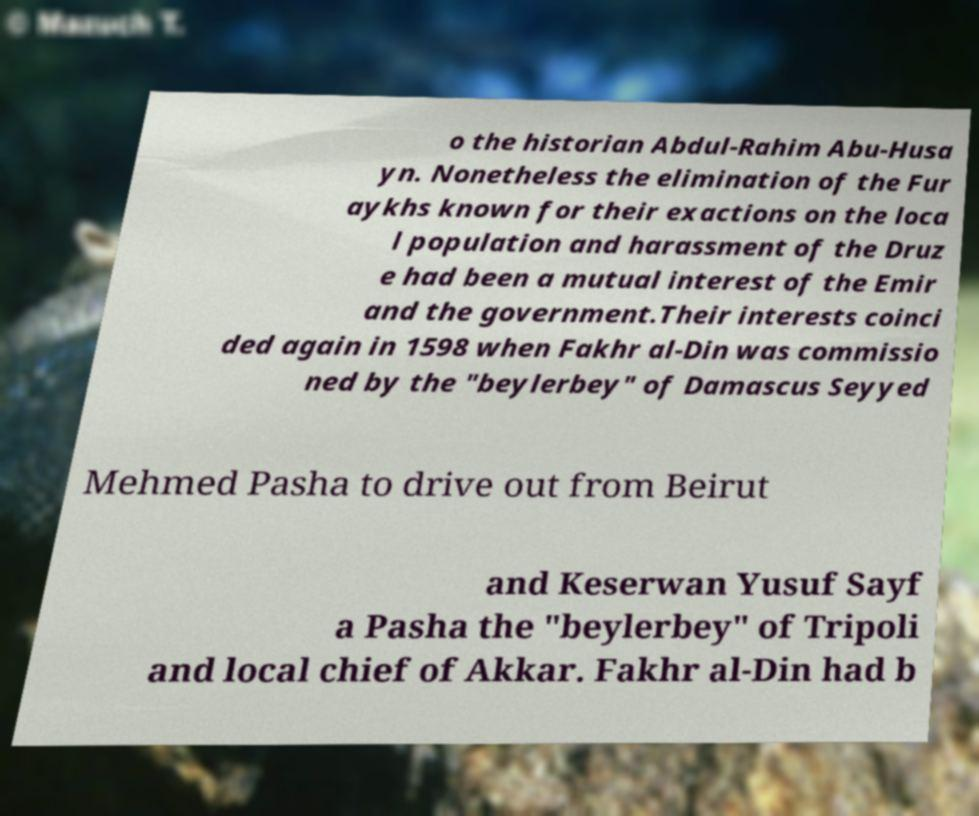Please identify and transcribe the text found in this image. o the historian Abdul-Rahim Abu-Husa yn. Nonetheless the elimination of the Fur aykhs known for their exactions on the loca l population and harassment of the Druz e had been a mutual interest of the Emir and the government.Their interests coinci ded again in 1598 when Fakhr al-Din was commissio ned by the "beylerbey" of Damascus Seyyed Mehmed Pasha to drive out from Beirut and Keserwan Yusuf Sayf a Pasha the "beylerbey" of Tripoli and local chief of Akkar. Fakhr al-Din had b 